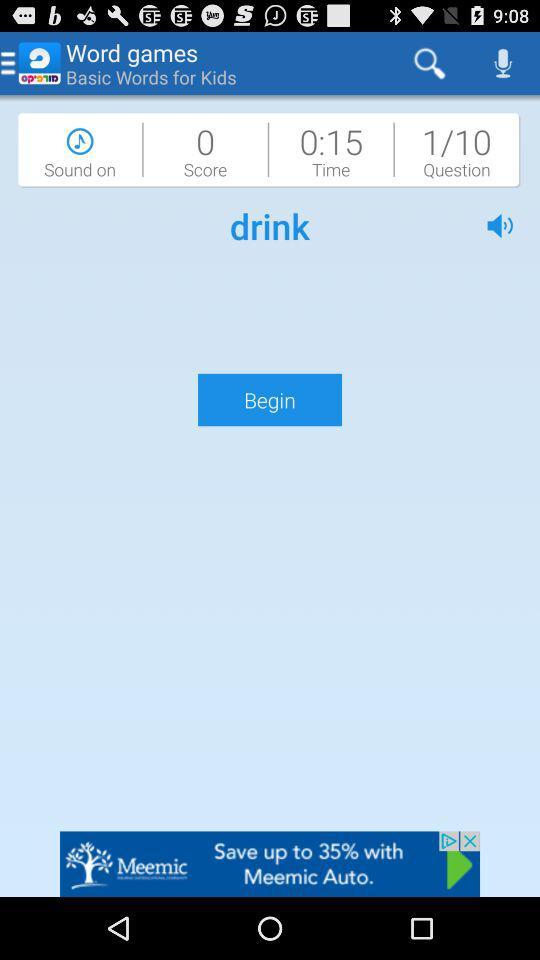How many questions are in "Word games"? There are 10 questions. 